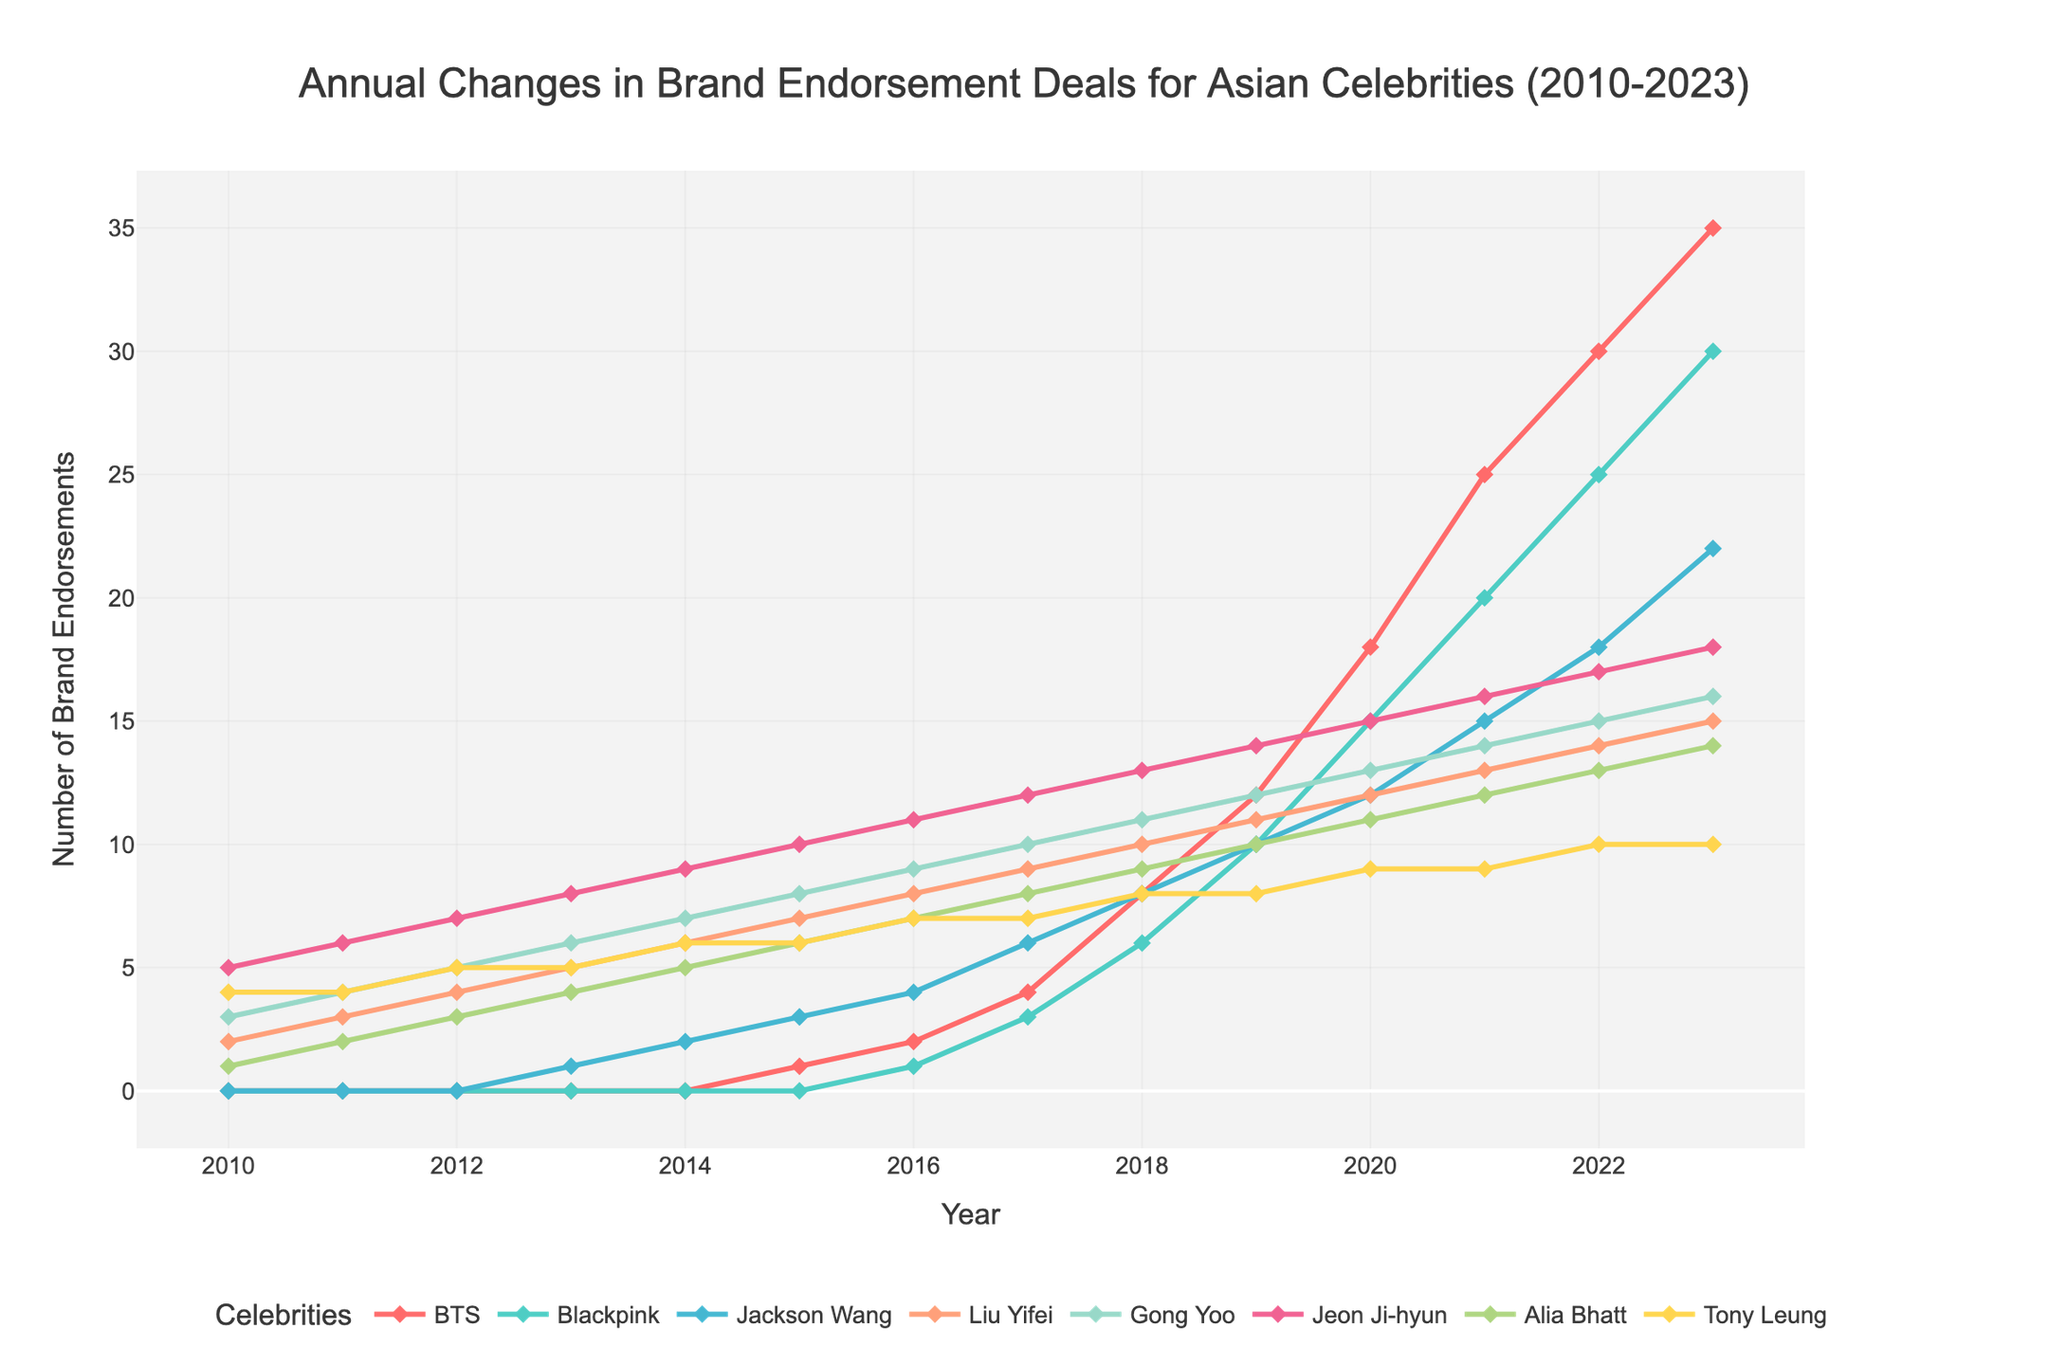What is the trend in the number of brand endorsements for BTS from 2010 to 2023? From 2010 to 2015, BTS had no brand endorsement deals. From 2016 onwards, there's a gradual increase, showing rapid growth after 2017, peaking at 35 endorsements in 2023.
Answer: There is a rapid increase after 2017, peaking at 35 in 2023 Which celebrity had the highest number of brand endorsements in 2023? To find this, locate the highest value on the y-axis in 2023. Based on the values, BTS has the highest endorsements at 35 in 2023.
Answer: BTS Compare the growth trend of brand endorsements for Blackpink and Jackson Wang from 2016 to 2023. From 2016 to 2023, both Blackpink and Jackson Wang show an increasing trend in endorsements. However, Blackpink's growth is more significant, increasing from 1 to 30, while Jackson Wang's grew from 4 to 22.
Answer: Blackpink’s growth was more significant By how much did the number of brand endorsements for Liu Yifei increase from 2010 to 2023? In 2010, Liu Yifei had 2 endorsements. In 2023, this increased to 15. The increase is calculated as 15 - 2 = 13.
Answer: 13 Which year did Gong Yoo and Jeon Ji-hyun have the same number of brand endorsements? Identify the intersection point of their lines on the plot. They had the same endorsements in 2012, both at 7.
Answer: 2012 What is the average number of brand endorsements for Tony Leung from 2010 to 2023? Sum the number of endorsements from 2010 to 2023 and divide by the number of years: (4+4+5+5+6+6+7+7+8+8+9+9+10)/14 = 6.93 (approximately).
Answer: Approximately 6.93 Which celebrity showed the most consistent growth in brand endorsements from 2010 to 2023? Liu Yifei’s trend is the most consistent, with a steady increase of one endorsement each year from 2010 to 2023 without any fluctuations or drops.
Answer: Liu Yifei How many brand endorsements did Blackpink have in 2018 as compared with 2023? In 2018, Blackpink had 6 endorsements, and in 2023, they had 30. So, the difference is 30 - 6 = 24.
Answer: 24 